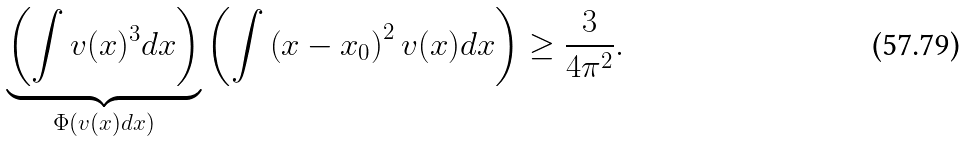Convert formula to latex. <formula><loc_0><loc_0><loc_500><loc_500>\underbrace { \left ( \int { v } ( x ) ^ { 3 } d x \right ) } _ { \Phi \left ( v ( x ) d x \right ) } \left ( \int \left ( x - x _ { 0 } \right ) ^ { 2 } v ( x ) d x \right ) \geq \frac { 3 } { 4 \pi ^ { 2 } } .</formula> 